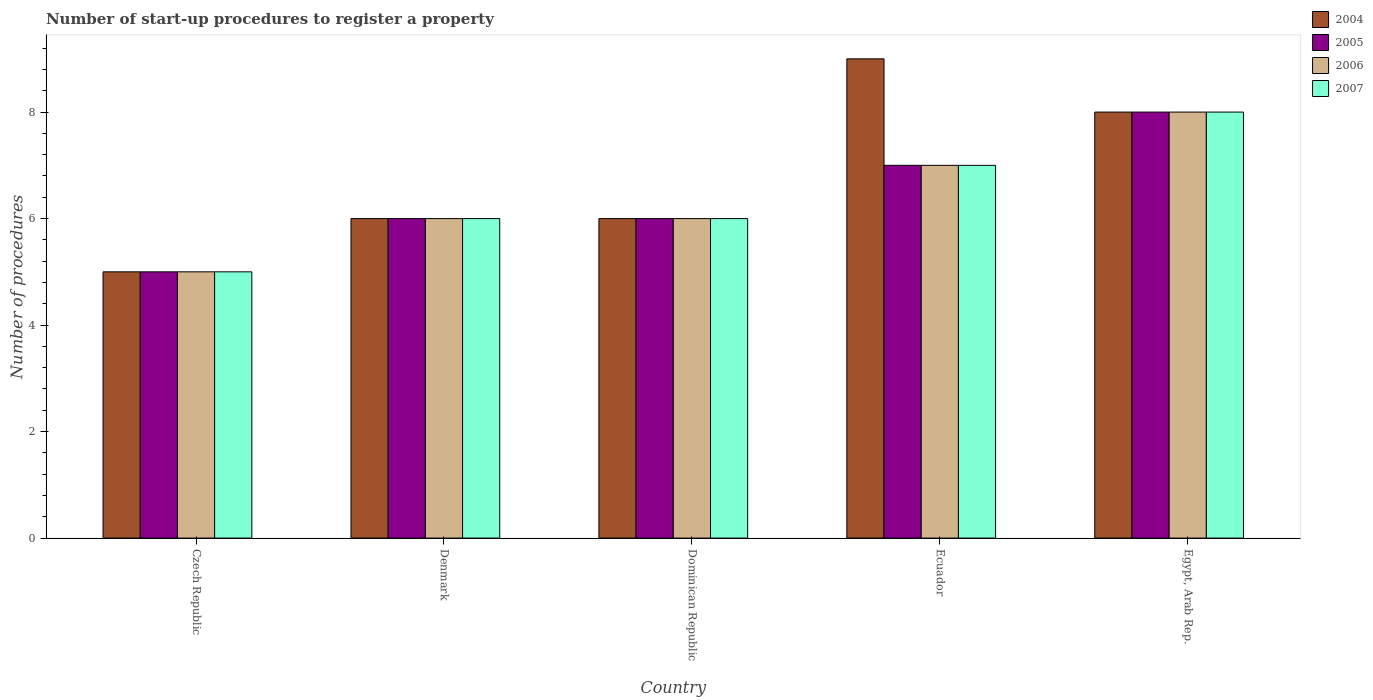How many different coloured bars are there?
Your response must be concise. 4. Are the number of bars per tick equal to the number of legend labels?
Make the answer very short. Yes. How many bars are there on the 4th tick from the right?
Keep it short and to the point. 4. In how many cases, is the number of bars for a given country not equal to the number of legend labels?
Offer a very short reply. 0. Across all countries, what is the maximum number of procedures required to register a property in 2005?
Keep it short and to the point. 8. In which country was the number of procedures required to register a property in 2007 maximum?
Provide a succinct answer. Egypt, Arab Rep. In which country was the number of procedures required to register a property in 2004 minimum?
Your response must be concise. Czech Republic. What is the difference between the number of procedures required to register a property in 2005 in Denmark and that in Ecuador?
Ensure brevity in your answer.  -1. What is the difference between the number of procedures required to register a property in 2007 in Denmark and the number of procedures required to register a property in 2004 in Egypt, Arab Rep.?
Keep it short and to the point. -2. In how many countries, is the number of procedures required to register a property in 2007 greater than 4.8?
Keep it short and to the point. 5. What is the ratio of the number of procedures required to register a property in 2005 in Ecuador to that in Egypt, Arab Rep.?
Your response must be concise. 0.88. Is the difference between the number of procedures required to register a property in 2007 in Czech Republic and Ecuador greater than the difference between the number of procedures required to register a property in 2005 in Czech Republic and Ecuador?
Make the answer very short. No. What is the difference between the highest and the second highest number of procedures required to register a property in 2007?
Ensure brevity in your answer.  2. What is the difference between the highest and the lowest number of procedures required to register a property in 2006?
Offer a terse response. 3. In how many countries, is the number of procedures required to register a property in 2007 greater than the average number of procedures required to register a property in 2007 taken over all countries?
Provide a short and direct response. 2. Is the sum of the number of procedures required to register a property in 2007 in Dominican Republic and Egypt, Arab Rep. greater than the maximum number of procedures required to register a property in 2006 across all countries?
Provide a short and direct response. Yes. What does the 3rd bar from the right in Egypt, Arab Rep. represents?
Offer a very short reply. 2005. Is it the case that in every country, the sum of the number of procedures required to register a property in 2005 and number of procedures required to register a property in 2007 is greater than the number of procedures required to register a property in 2004?
Your response must be concise. Yes. Are all the bars in the graph horizontal?
Keep it short and to the point. No. How many countries are there in the graph?
Your answer should be very brief. 5. What is the difference between two consecutive major ticks on the Y-axis?
Your answer should be compact. 2. Are the values on the major ticks of Y-axis written in scientific E-notation?
Offer a very short reply. No. Does the graph contain any zero values?
Provide a succinct answer. No. Where does the legend appear in the graph?
Keep it short and to the point. Top right. How are the legend labels stacked?
Ensure brevity in your answer.  Vertical. What is the title of the graph?
Provide a succinct answer. Number of start-up procedures to register a property. Does "1991" appear as one of the legend labels in the graph?
Your response must be concise. No. What is the label or title of the Y-axis?
Give a very brief answer. Number of procedures. What is the Number of procedures of 2005 in Czech Republic?
Keep it short and to the point. 5. What is the Number of procedures in 2004 in Denmark?
Provide a succinct answer. 6. What is the Number of procedures of 2005 in Denmark?
Provide a short and direct response. 6. What is the Number of procedures in 2006 in Denmark?
Provide a short and direct response. 6. What is the Number of procedures of 2007 in Denmark?
Provide a succinct answer. 6. What is the Number of procedures in 2004 in Dominican Republic?
Your answer should be very brief. 6. What is the Number of procedures of 2006 in Ecuador?
Offer a very short reply. 7. What is the Number of procedures of 2007 in Egypt, Arab Rep.?
Offer a very short reply. 8. Across all countries, what is the maximum Number of procedures of 2004?
Give a very brief answer. 9. Across all countries, what is the maximum Number of procedures in 2006?
Your answer should be compact. 8. Across all countries, what is the maximum Number of procedures in 2007?
Provide a short and direct response. 8. Across all countries, what is the minimum Number of procedures of 2004?
Make the answer very short. 5. Across all countries, what is the minimum Number of procedures in 2005?
Your response must be concise. 5. Across all countries, what is the minimum Number of procedures of 2007?
Keep it short and to the point. 5. What is the total Number of procedures in 2004 in the graph?
Keep it short and to the point. 34. What is the total Number of procedures in 2005 in the graph?
Your response must be concise. 32. What is the difference between the Number of procedures of 2006 in Czech Republic and that in Denmark?
Give a very brief answer. -1. What is the difference between the Number of procedures of 2007 in Czech Republic and that in Denmark?
Give a very brief answer. -1. What is the difference between the Number of procedures in 2005 in Czech Republic and that in Dominican Republic?
Offer a very short reply. -1. What is the difference between the Number of procedures of 2007 in Czech Republic and that in Dominican Republic?
Keep it short and to the point. -1. What is the difference between the Number of procedures in 2004 in Czech Republic and that in Ecuador?
Make the answer very short. -4. What is the difference between the Number of procedures in 2005 in Czech Republic and that in Ecuador?
Keep it short and to the point. -2. What is the difference between the Number of procedures in 2006 in Czech Republic and that in Ecuador?
Provide a short and direct response. -2. What is the difference between the Number of procedures of 2007 in Czech Republic and that in Ecuador?
Offer a terse response. -2. What is the difference between the Number of procedures in 2004 in Czech Republic and that in Egypt, Arab Rep.?
Give a very brief answer. -3. What is the difference between the Number of procedures of 2006 in Czech Republic and that in Egypt, Arab Rep.?
Provide a succinct answer. -3. What is the difference between the Number of procedures of 2007 in Czech Republic and that in Egypt, Arab Rep.?
Make the answer very short. -3. What is the difference between the Number of procedures in 2005 in Denmark and that in Dominican Republic?
Offer a very short reply. 0. What is the difference between the Number of procedures in 2005 in Denmark and that in Ecuador?
Make the answer very short. -1. What is the difference between the Number of procedures in 2004 in Denmark and that in Egypt, Arab Rep.?
Ensure brevity in your answer.  -2. What is the difference between the Number of procedures in 2006 in Denmark and that in Egypt, Arab Rep.?
Provide a short and direct response. -2. What is the difference between the Number of procedures of 2007 in Denmark and that in Egypt, Arab Rep.?
Ensure brevity in your answer.  -2. What is the difference between the Number of procedures of 2005 in Dominican Republic and that in Ecuador?
Offer a very short reply. -1. What is the difference between the Number of procedures in 2006 in Dominican Republic and that in Ecuador?
Provide a succinct answer. -1. What is the difference between the Number of procedures of 2007 in Dominican Republic and that in Ecuador?
Your answer should be very brief. -1. What is the difference between the Number of procedures in 2004 in Dominican Republic and that in Egypt, Arab Rep.?
Keep it short and to the point. -2. What is the difference between the Number of procedures of 2006 in Dominican Republic and that in Egypt, Arab Rep.?
Offer a terse response. -2. What is the difference between the Number of procedures of 2004 in Ecuador and that in Egypt, Arab Rep.?
Provide a succinct answer. 1. What is the difference between the Number of procedures of 2006 in Ecuador and that in Egypt, Arab Rep.?
Offer a very short reply. -1. What is the difference between the Number of procedures of 2007 in Ecuador and that in Egypt, Arab Rep.?
Your answer should be very brief. -1. What is the difference between the Number of procedures of 2004 in Czech Republic and the Number of procedures of 2005 in Denmark?
Make the answer very short. -1. What is the difference between the Number of procedures of 2004 in Czech Republic and the Number of procedures of 2006 in Denmark?
Provide a short and direct response. -1. What is the difference between the Number of procedures of 2005 in Czech Republic and the Number of procedures of 2007 in Denmark?
Give a very brief answer. -1. What is the difference between the Number of procedures of 2006 in Czech Republic and the Number of procedures of 2007 in Denmark?
Offer a terse response. -1. What is the difference between the Number of procedures of 2004 in Czech Republic and the Number of procedures of 2006 in Dominican Republic?
Your response must be concise. -1. What is the difference between the Number of procedures in 2005 in Czech Republic and the Number of procedures in 2007 in Dominican Republic?
Make the answer very short. -1. What is the difference between the Number of procedures in 2004 in Czech Republic and the Number of procedures in 2005 in Ecuador?
Your answer should be compact. -2. What is the difference between the Number of procedures of 2004 in Czech Republic and the Number of procedures of 2007 in Ecuador?
Keep it short and to the point. -2. What is the difference between the Number of procedures of 2006 in Czech Republic and the Number of procedures of 2007 in Ecuador?
Provide a succinct answer. -2. What is the difference between the Number of procedures in 2004 in Czech Republic and the Number of procedures in 2006 in Egypt, Arab Rep.?
Ensure brevity in your answer.  -3. What is the difference between the Number of procedures of 2004 in Czech Republic and the Number of procedures of 2007 in Egypt, Arab Rep.?
Offer a terse response. -3. What is the difference between the Number of procedures in 2004 in Denmark and the Number of procedures in 2006 in Dominican Republic?
Give a very brief answer. 0. What is the difference between the Number of procedures of 2005 in Denmark and the Number of procedures of 2006 in Dominican Republic?
Ensure brevity in your answer.  0. What is the difference between the Number of procedures in 2006 in Denmark and the Number of procedures in 2007 in Dominican Republic?
Offer a terse response. 0. What is the difference between the Number of procedures in 2004 in Denmark and the Number of procedures in 2005 in Ecuador?
Provide a succinct answer. -1. What is the difference between the Number of procedures of 2004 in Denmark and the Number of procedures of 2007 in Ecuador?
Provide a succinct answer. -1. What is the difference between the Number of procedures in 2005 in Denmark and the Number of procedures in 2006 in Ecuador?
Your response must be concise. -1. What is the difference between the Number of procedures of 2004 in Denmark and the Number of procedures of 2005 in Egypt, Arab Rep.?
Your answer should be compact. -2. What is the difference between the Number of procedures in 2005 in Denmark and the Number of procedures in 2006 in Egypt, Arab Rep.?
Your response must be concise. -2. What is the difference between the Number of procedures in 2005 in Denmark and the Number of procedures in 2007 in Egypt, Arab Rep.?
Keep it short and to the point. -2. What is the difference between the Number of procedures of 2006 in Denmark and the Number of procedures of 2007 in Egypt, Arab Rep.?
Your response must be concise. -2. What is the difference between the Number of procedures in 2004 in Dominican Republic and the Number of procedures in 2005 in Ecuador?
Offer a terse response. -1. What is the difference between the Number of procedures of 2004 in Dominican Republic and the Number of procedures of 2006 in Ecuador?
Keep it short and to the point. -1. What is the difference between the Number of procedures of 2004 in Dominican Republic and the Number of procedures of 2007 in Ecuador?
Your answer should be compact. -1. What is the difference between the Number of procedures of 2005 in Dominican Republic and the Number of procedures of 2006 in Ecuador?
Provide a succinct answer. -1. What is the difference between the Number of procedures in 2004 in Dominican Republic and the Number of procedures in 2005 in Egypt, Arab Rep.?
Provide a short and direct response. -2. What is the difference between the Number of procedures in 2004 in Dominican Republic and the Number of procedures in 2006 in Egypt, Arab Rep.?
Make the answer very short. -2. What is the difference between the Number of procedures of 2004 in Dominican Republic and the Number of procedures of 2007 in Egypt, Arab Rep.?
Your answer should be compact. -2. What is the difference between the Number of procedures of 2005 in Dominican Republic and the Number of procedures of 2007 in Egypt, Arab Rep.?
Give a very brief answer. -2. What is the difference between the Number of procedures of 2004 in Ecuador and the Number of procedures of 2005 in Egypt, Arab Rep.?
Your answer should be compact. 1. What is the difference between the Number of procedures in 2004 in Ecuador and the Number of procedures in 2006 in Egypt, Arab Rep.?
Your answer should be compact. 1. What is the difference between the Number of procedures of 2004 in Ecuador and the Number of procedures of 2007 in Egypt, Arab Rep.?
Your response must be concise. 1. What is the difference between the Number of procedures in 2005 in Ecuador and the Number of procedures in 2006 in Egypt, Arab Rep.?
Your answer should be very brief. -1. What is the difference between the Number of procedures of 2006 in Ecuador and the Number of procedures of 2007 in Egypt, Arab Rep.?
Ensure brevity in your answer.  -1. What is the average Number of procedures of 2004 per country?
Your answer should be compact. 6.8. What is the average Number of procedures in 2007 per country?
Provide a succinct answer. 6.4. What is the difference between the Number of procedures of 2005 and Number of procedures of 2006 in Czech Republic?
Provide a succinct answer. 0. What is the difference between the Number of procedures of 2005 and Number of procedures of 2007 in Czech Republic?
Your answer should be compact. 0. What is the difference between the Number of procedures in 2006 and Number of procedures in 2007 in Czech Republic?
Give a very brief answer. 0. What is the difference between the Number of procedures of 2005 and Number of procedures of 2007 in Denmark?
Provide a short and direct response. 0. What is the difference between the Number of procedures in 2004 and Number of procedures in 2005 in Dominican Republic?
Provide a short and direct response. 0. What is the difference between the Number of procedures of 2004 and Number of procedures of 2007 in Dominican Republic?
Make the answer very short. 0. What is the difference between the Number of procedures of 2004 and Number of procedures of 2006 in Ecuador?
Make the answer very short. 2. What is the difference between the Number of procedures in 2004 and Number of procedures in 2007 in Ecuador?
Provide a succinct answer. 2. What is the difference between the Number of procedures of 2006 and Number of procedures of 2007 in Ecuador?
Make the answer very short. 0. What is the difference between the Number of procedures of 2004 and Number of procedures of 2005 in Egypt, Arab Rep.?
Your answer should be very brief. 0. What is the difference between the Number of procedures of 2004 and Number of procedures of 2006 in Egypt, Arab Rep.?
Offer a very short reply. 0. What is the difference between the Number of procedures in 2005 and Number of procedures in 2006 in Egypt, Arab Rep.?
Give a very brief answer. 0. What is the ratio of the Number of procedures in 2004 in Czech Republic to that in Denmark?
Your answer should be compact. 0.83. What is the ratio of the Number of procedures of 2007 in Czech Republic to that in Denmark?
Keep it short and to the point. 0.83. What is the ratio of the Number of procedures of 2004 in Czech Republic to that in Dominican Republic?
Provide a succinct answer. 0.83. What is the ratio of the Number of procedures in 2006 in Czech Republic to that in Dominican Republic?
Give a very brief answer. 0.83. What is the ratio of the Number of procedures in 2007 in Czech Republic to that in Dominican Republic?
Your response must be concise. 0.83. What is the ratio of the Number of procedures of 2004 in Czech Republic to that in Ecuador?
Ensure brevity in your answer.  0.56. What is the ratio of the Number of procedures in 2005 in Czech Republic to that in Ecuador?
Ensure brevity in your answer.  0.71. What is the ratio of the Number of procedures in 2006 in Czech Republic to that in Ecuador?
Offer a very short reply. 0.71. What is the ratio of the Number of procedures in 2006 in Czech Republic to that in Egypt, Arab Rep.?
Ensure brevity in your answer.  0.62. What is the ratio of the Number of procedures in 2007 in Denmark to that in Dominican Republic?
Offer a terse response. 1. What is the ratio of the Number of procedures of 2004 in Denmark to that in Ecuador?
Ensure brevity in your answer.  0.67. What is the ratio of the Number of procedures in 2005 in Denmark to that in Ecuador?
Provide a succinct answer. 0.86. What is the ratio of the Number of procedures in 2006 in Denmark to that in Ecuador?
Make the answer very short. 0.86. What is the ratio of the Number of procedures in 2005 in Denmark to that in Egypt, Arab Rep.?
Ensure brevity in your answer.  0.75. What is the ratio of the Number of procedures of 2005 in Dominican Republic to that in Ecuador?
Your response must be concise. 0.86. What is the ratio of the Number of procedures of 2006 in Dominican Republic to that in Ecuador?
Provide a succinct answer. 0.86. What is the ratio of the Number of procedures in 2005 in Dominican Republic to that in Egypt, Arab Rep.?
Provide a short and direct response. 0.75. What is the ratio of the Number of procedures of 2006 in Dominican Republic to that in Egypt, Arab Rep.?
Make the answer very short. 0.75. What is the ratio of the Number of procedures of 2004 in Ecuador to that in Egypt, Arab Rep.?
Give a very brief answer. 1.12. What is the ratio of the Number of procedures of 2005 in Ecuador to that in Egypt, Arab Rep.?
Your answer should be very brief. 0.88. What is the ratio of the Number of procedures in 2006 in Ecuador to that in Egypt, Arab Rep.?
Offer a very short reply. 0.88. What is the ratio of the Number of procedures in 2007 in Ecuador to that in Egypt, Arab Rep.?
Offer a very short reply. 0.88. What is the difference between the highest and the second highest Number of procedures of 2004?
Offer a very short reply. 1. What is the difference between the highest and the second highest Number of procedures in 2006?
Offer a terse response. 1. What is the difference between the highest and the second highest Number of procedures in 2007?
Offer a very short reply. 1. What is the difference between the highest and the lowest Number of procedures in 2004?
Your answer should be compact. 4. What is the difference between the highest and the lowest Number of procedures in 2007?
Ensure brevity in your answer.  3. 